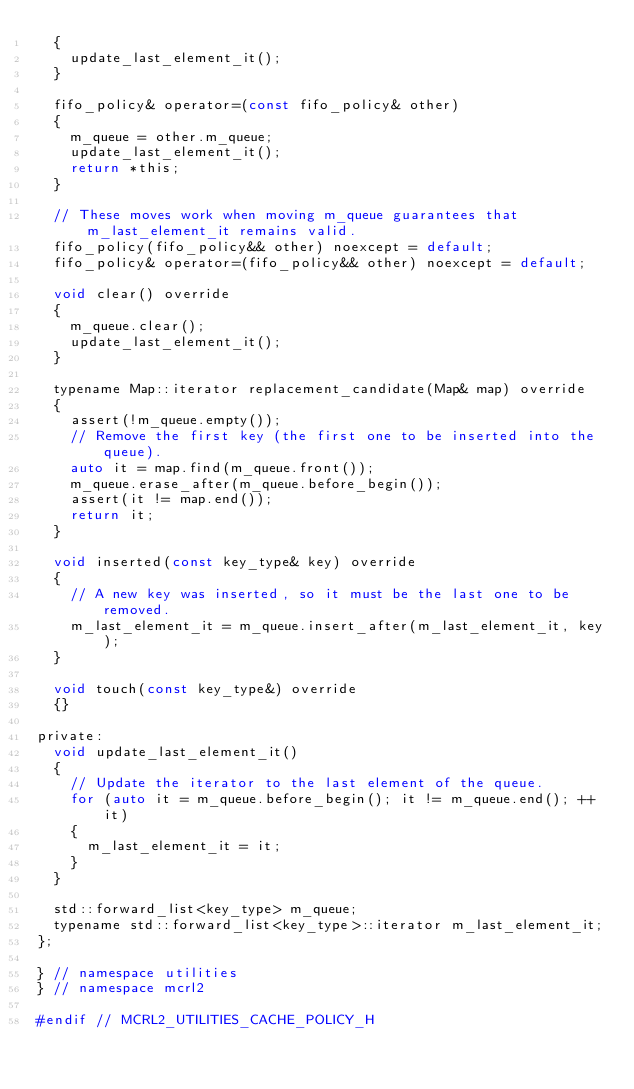Convert code to text. <code><loc_0><loc_0><loc_500><loc_500><_C_>  {
    update_last_element_it();
  }

  fifo_policy& operator=(const fifo_policy& other)
  {
    m_queue = other.m_queue;
    update_last_element_it();
    return *this;
  }

  // These moves work when moving m_queue guarantees that m_last_element_it remains valid.
  fifo_policy(fifo_policy&& other) noexcept = default;
  fifo_policy& operator=(fifo_policy&& other) noexcept = default;

  void clear() override
  {
    m_queue.clear();
    update_last_element_it();
  }

  typename Map::iterator replacement_candidate(Map& map) override
  {
    assert(!m_queue.empty());
    // Remove the first key (the first one to be inserted into the queue).
    auto it = map.find(m_queue.front());
    m_queue.erase_after(m_queue.before_begin());
    assert(it != map.end());
    return it;
  }

  void inserted(const key_type& key) override
  {
    // A new key was inserted, so it must be the last one to be removed.
    m_last_element_it = m_queue.insert_after(m_last_element_it, key);
  }

  void touch(const key_type&) override
  {}

private:
  void update_last_element_it()
  {
    // Update the iterator to the last element of the queue.
    for (auto it = m_queue.before_begin(); it != m_queue.end(); ++it)
    {
      m_last_element_it = it;
    }
  }

  std::forward_list<key_type> m_queue;
  typename std::forward_list<key_type>::iterator m_last_element_it;
};

} // namespace utilities
} // namespace mcrl2

#endif // MCRL2_UTILITIES_CACHE_POLICY_H
</code> 